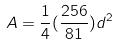<formula> <loc_0><loc_0><loc_500><loc_500>A = \frac { 1 } { 4 } ( \frac { 2 5 6 } { 8 1 } ) d ^ { 2 }</formula> 